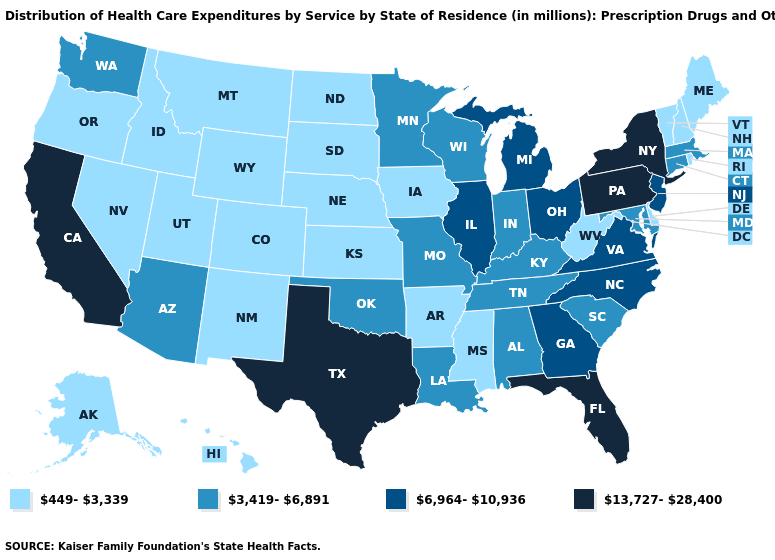Does Kansas have a lower value than Oklahoma?
Be succinct. Yes. What is the lowest value in the South?
Give a very brief answer. 449-3,339. Which states hav the highest value in the Northeast?
Short answer required. New York, Pennsylvania. Does Montana have a lower value than Alaska?
Short answer required. No. Name the states that have a value in the range 3,419-6,891?
Concise answer only. Alabama, Arizona, Connecticut, Indiana, Kentucky, Louisiana, Maryland, Massachusetts, Minnesota, Missouri, Oklahoma, South Carolina, Tennessee, Washington, Wisconsin. What is the value of South Dakota?
Be succinct. 449-3,339. What is the lowest value in the MidWest?
Concise answer only. 449-3,339. Does Georgia have the same value as Wisconsin?
Answer briefly. No. How many symbols are there in the legend?
Answer briefly. 4. Does Minnesota have the lowest value in the MidWest?
Keep it brief. No. Name the states that have a value in the range 6,964-10,936?
Quick response, please. Georgia, Illinois, Michigan, New Jersey, North Carolina, Ohio, Virginia. Does Texas have the highest value in the USA?
Be succinct. Yes. Among the states that border Oregon , does California have the lowest value?
Keep it brief. No. Among the states that border Florida , which have the lowest value?
Quick response, please. Alabama. Which states have the highest value in the USA?
Write a very short answer. California, Florida, New York, Pennsylvania, Texas. 